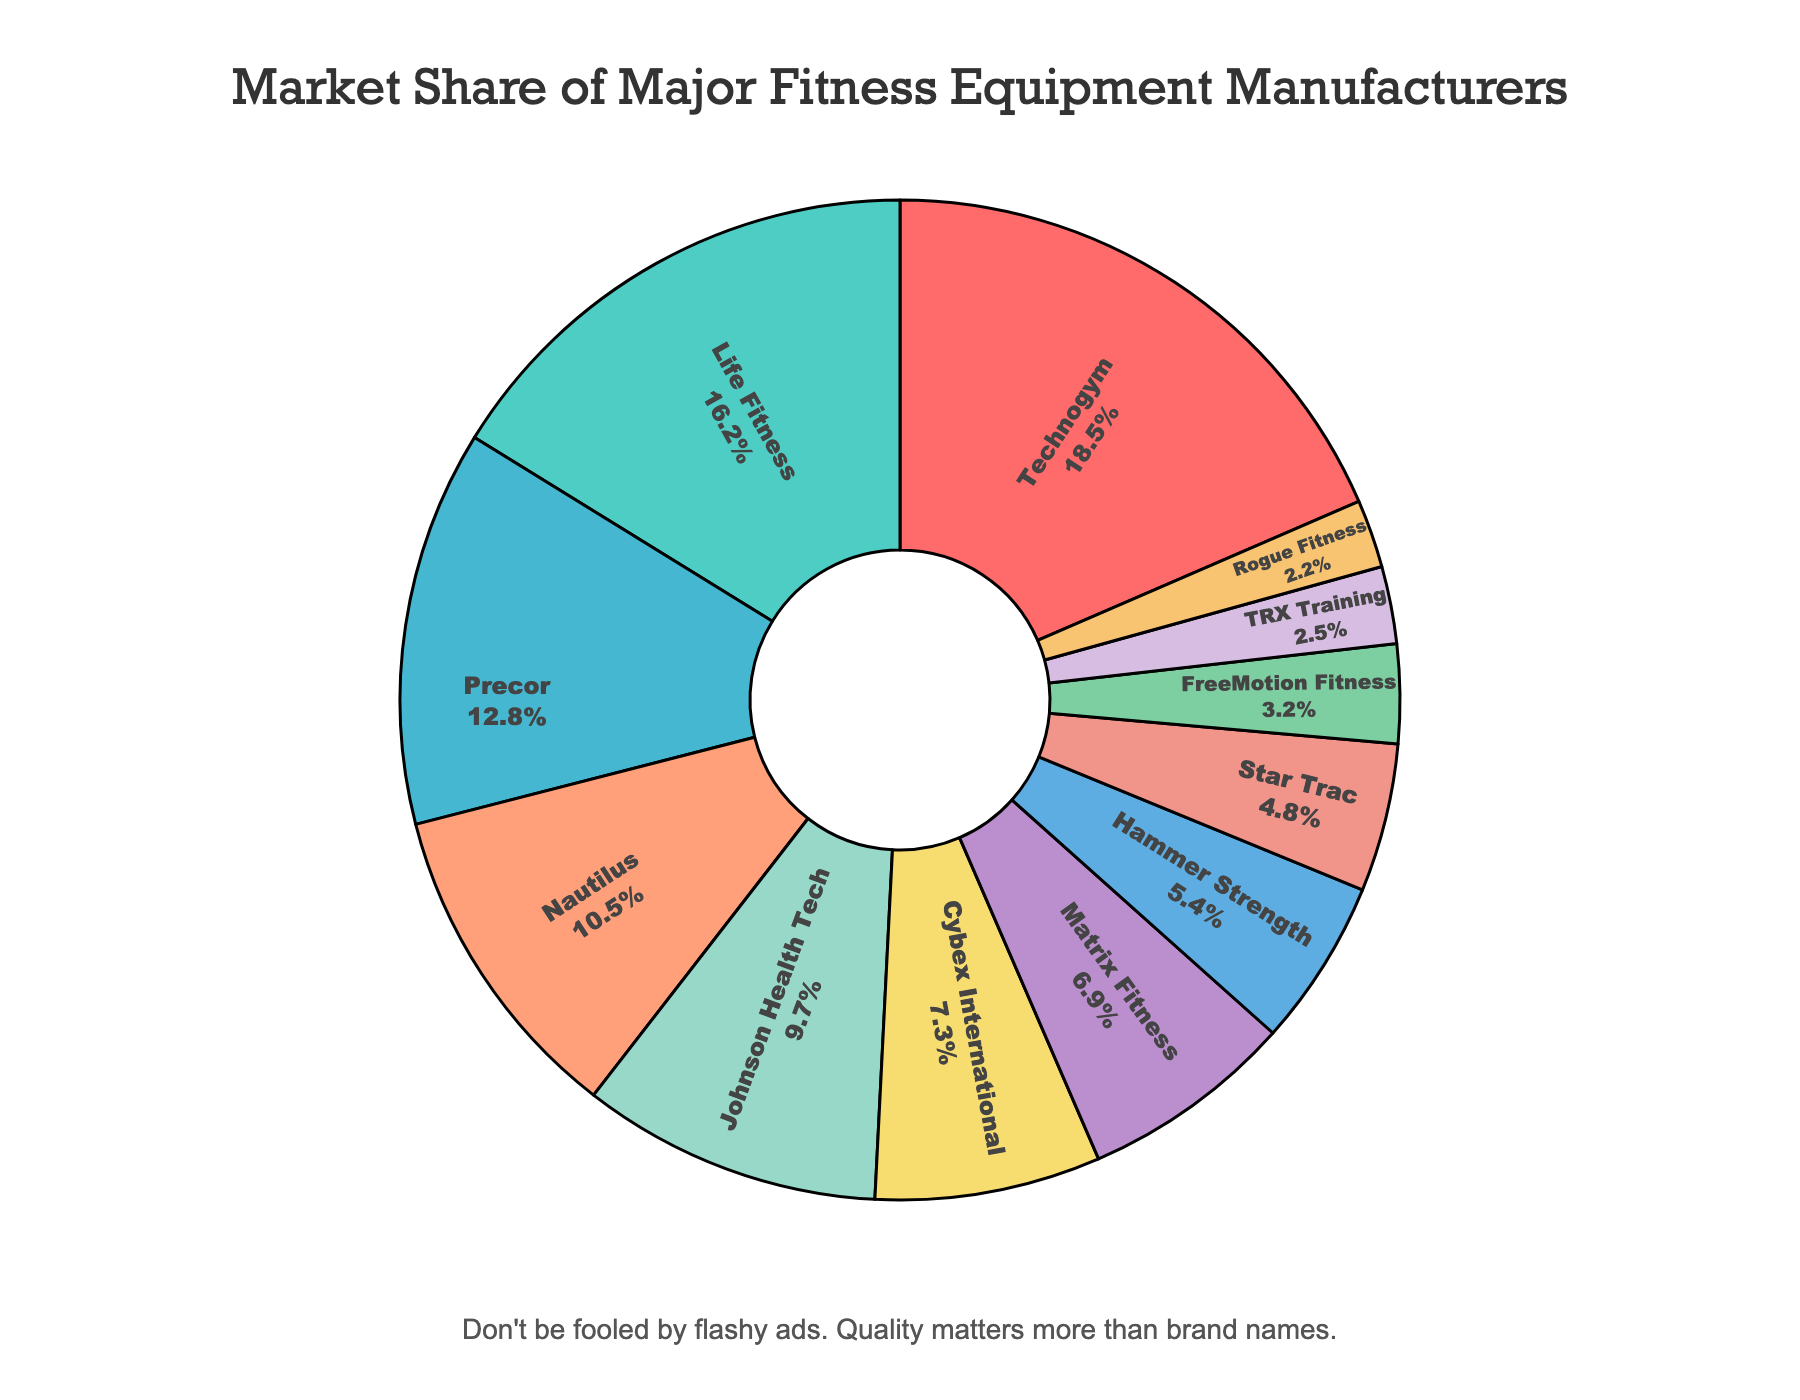What's the total market share of Technogym and Life Fitness? Add the market share of Technogym (18.5%) and Life Fitness (16.2%). The total is 18.5 + 16.2 = 34.7%.
Answer: 34.7% Which company has a larger market share, Precor or Cybex International? Compare the market share of Precor (12.8%) with Cybex International (7.3%). Precor has a larger market share.
Answer: Precor What is the difference in market share between Johnson Health Tech and Hammer Strength? Subtract the market share of Hammer Strength (5.4%) from Johnson Health Tech (9.7%). The difference is 9.7 - 5.4 = 4.3%.
Answer: 4.3% Which company occupies the smallest market share? Identify the company with the smallest percentage. TRX Training has 2.2%, which is the smallest.
Answer: TRX Training What is the combined market share of the three companies with the least market share? Add the market share percentages of the three companies with the smallest shares: TRX Training (2.5%), Rogue Fitness (2.2%), and FreeMotion Fitness (3.2%). The combined market share is 2.5 + 2.2 + 3.2 = 7.9%.
Answer: 7.9% Which two companies have market shares closest to each other? Compare the market share values and find the closest pair: Hammer Strength (5.4%) and Star Trac (4.8%) differ by only 0.6%.
Answer: Hammer Strength and Star Trac What percentage of the market is controlled by the top four companies? Add the market shares of the top four companies: Technogym (18.5%), Life Fitness (16.2%), Precor (12.8%), and Nautilus (10.5%). The total is 18.5 + 16.2 + 12.8 + 10.5 = 58%.
Answer: 58% Who has a larger market share, Matrix Fitness or FreeMotion Fitness, and by how much? Compare the market shares of Matrix Fitness (6.9%) and FreeMotion Fitness (3.2%). The difference is 6.9 - 3.2 = 3.7%.
Answer: Matrix Fitness by 3.7% What is the average market share of the companies listed (round to two decimal places)? Add all the market shares and divide by the number of companies: (18.5 + 16.2 + 12.8 + 10.5 + 9.7 + 7.3 + 6.9 + 5.4 + 4.8 + 3.2 + 2.5 + 2.2)/12 ≈ 8.125%.
Answer: 8.13% What color represents Johnson Health Tech in the pie chart? Based on the provided custom color palette, match the color sequence with the company list. Johnson Health Tech is the 5th company, so it is represented by '#98D8C8' which is a light green color.
Answer: Light green 